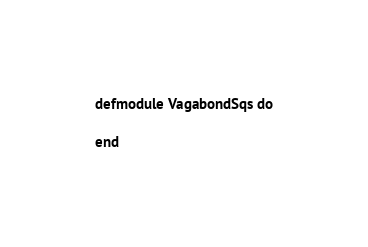Convert code to text. <code><loc_0><loc_0><loc_500><loc_500><_Elixir_>defmodule VagabondSqs do

end
</code> 